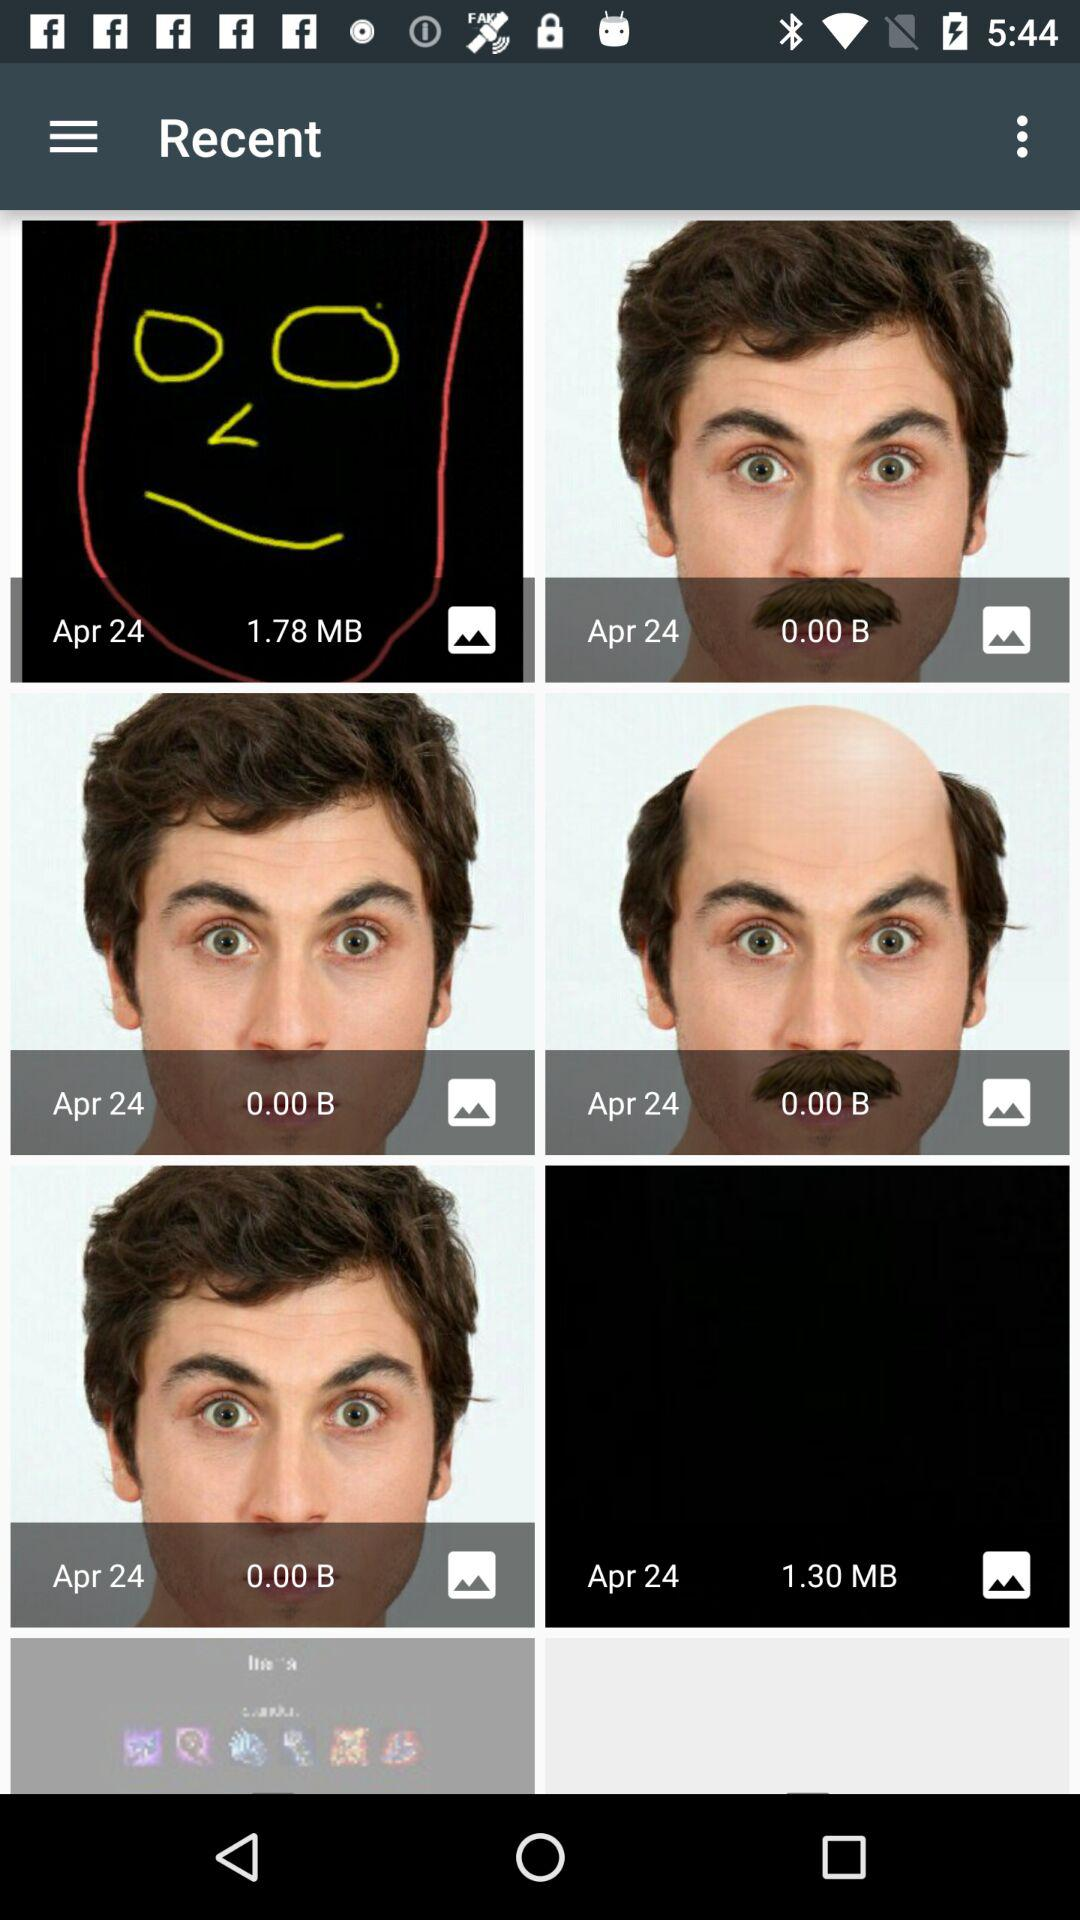What is the mentioned date? The mentioned date is April 24. 